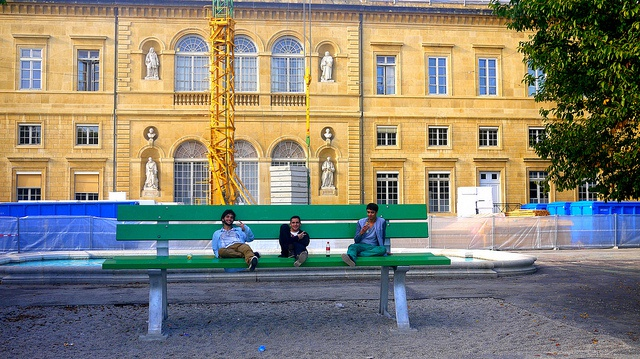Describe the objects in this image and their specific colors. I can see bench in black, teal, darkgreen, and lightgray tones, people in black, teal, navy, and blue tones, people in black, lightblue, and gray tones, and people in black, gray, teal, and white tones in this image. 